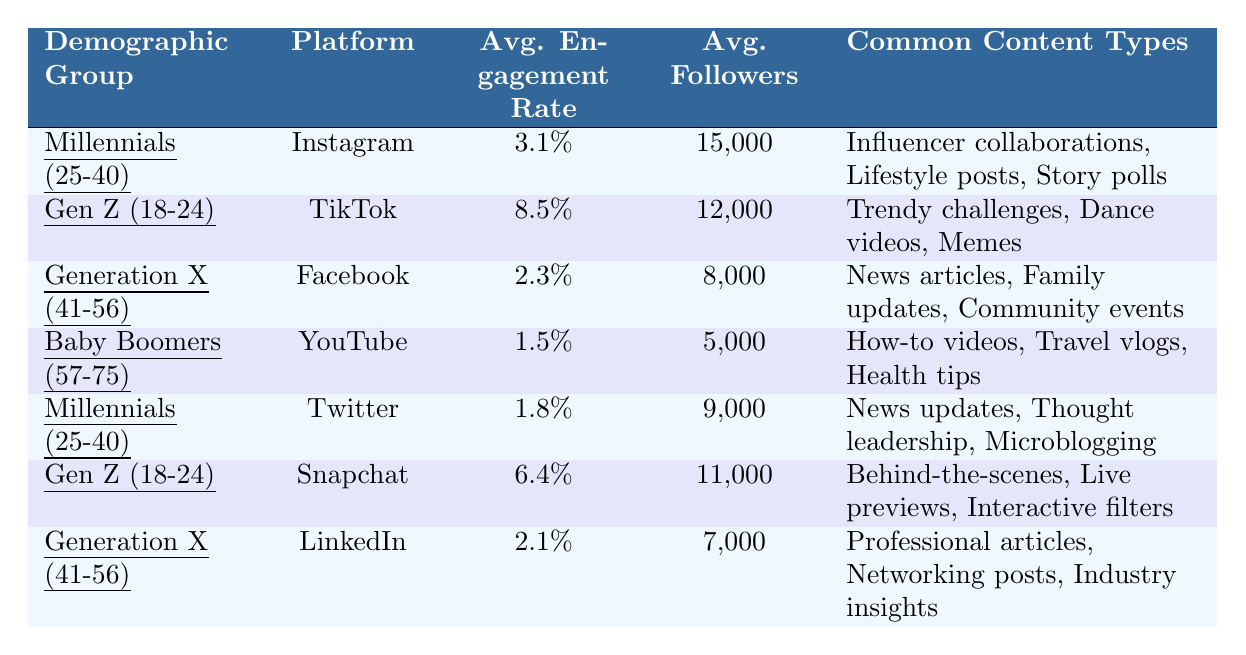What is the average engagement rate for Millennials on Instagram? According to the table, the average engagement rate for Millennials on Instagram is stated as 3.1%.
Answer: 3.1% Which demographic group has the highest average engagement rate? The table indicates that Gen Z (18-24) on TikTok has the highest average engagement rate at 8.5%.
Answer: Gen Z (18-24) on TikTok How many average followers does Baby Boomers have on YouTube? The table shows that Baby Boomers have an average of 5,000 followers on YouTube.
Answer: 5,000 What are the common content types for Generation X on Facebook? The table lists the common content types for Generation X on Facebook as news articles, family updates, and community events.
Answer: News articles, family updates, community events Which demographic group has the least average followers, and how many is it? The table shows that Baby Boomers have the least average followers, with a count of 5,000.
Answer: Baby Boomers, 5,000 What is the difference in average engagement rates between Millennials on Instagram and Baby Boomers on YouTube? Millennials on Instagram have an engagement rate of 3.1% and Baby Boomers on YouTube have 1.5%. The difference is 3.1% - 1.5% = 1.6%.
Answer: 1.6% If we combine the average followers of Gen Z on TikTok and Snapchat, what is the total? The average followers for Gen Z on TikTok is 12,000 and on Snapchat is 11,000. Adding these gives 12,000 + 11,000 = 23,000.
Answer: 23,000 Is the average engagement rate for Generation X lower than that of Millennials on Twitter? Generation X has an average engagement rate of 2.1% on LinkedIn, while Millennials on Twitter have 1.8%. Since 2.1% is greater than 1.8%, this statement is false.
Answer: No Considering the average engagement rates, which platform is prioritized for Gen Z and why? Gen Z has the highest engagement rate (8.5%) on TikTok compared to their 6.4% on Snapchat, indicating TikTok is prioritized for engaging this demographic.
Answer: TikTok, because it has the highest engagement rate at 8.5% How does the average engagement rate for Millennials on Twitter compare to that of Generation X on Facebook? Millennials on Twitter have a rate of 1.8%, while Generation X on Facebook has 2.3%. Since 1.8% is lower than 2.3%, Millennials on Twitter have a lower engagement rate.
Answer: Lower 